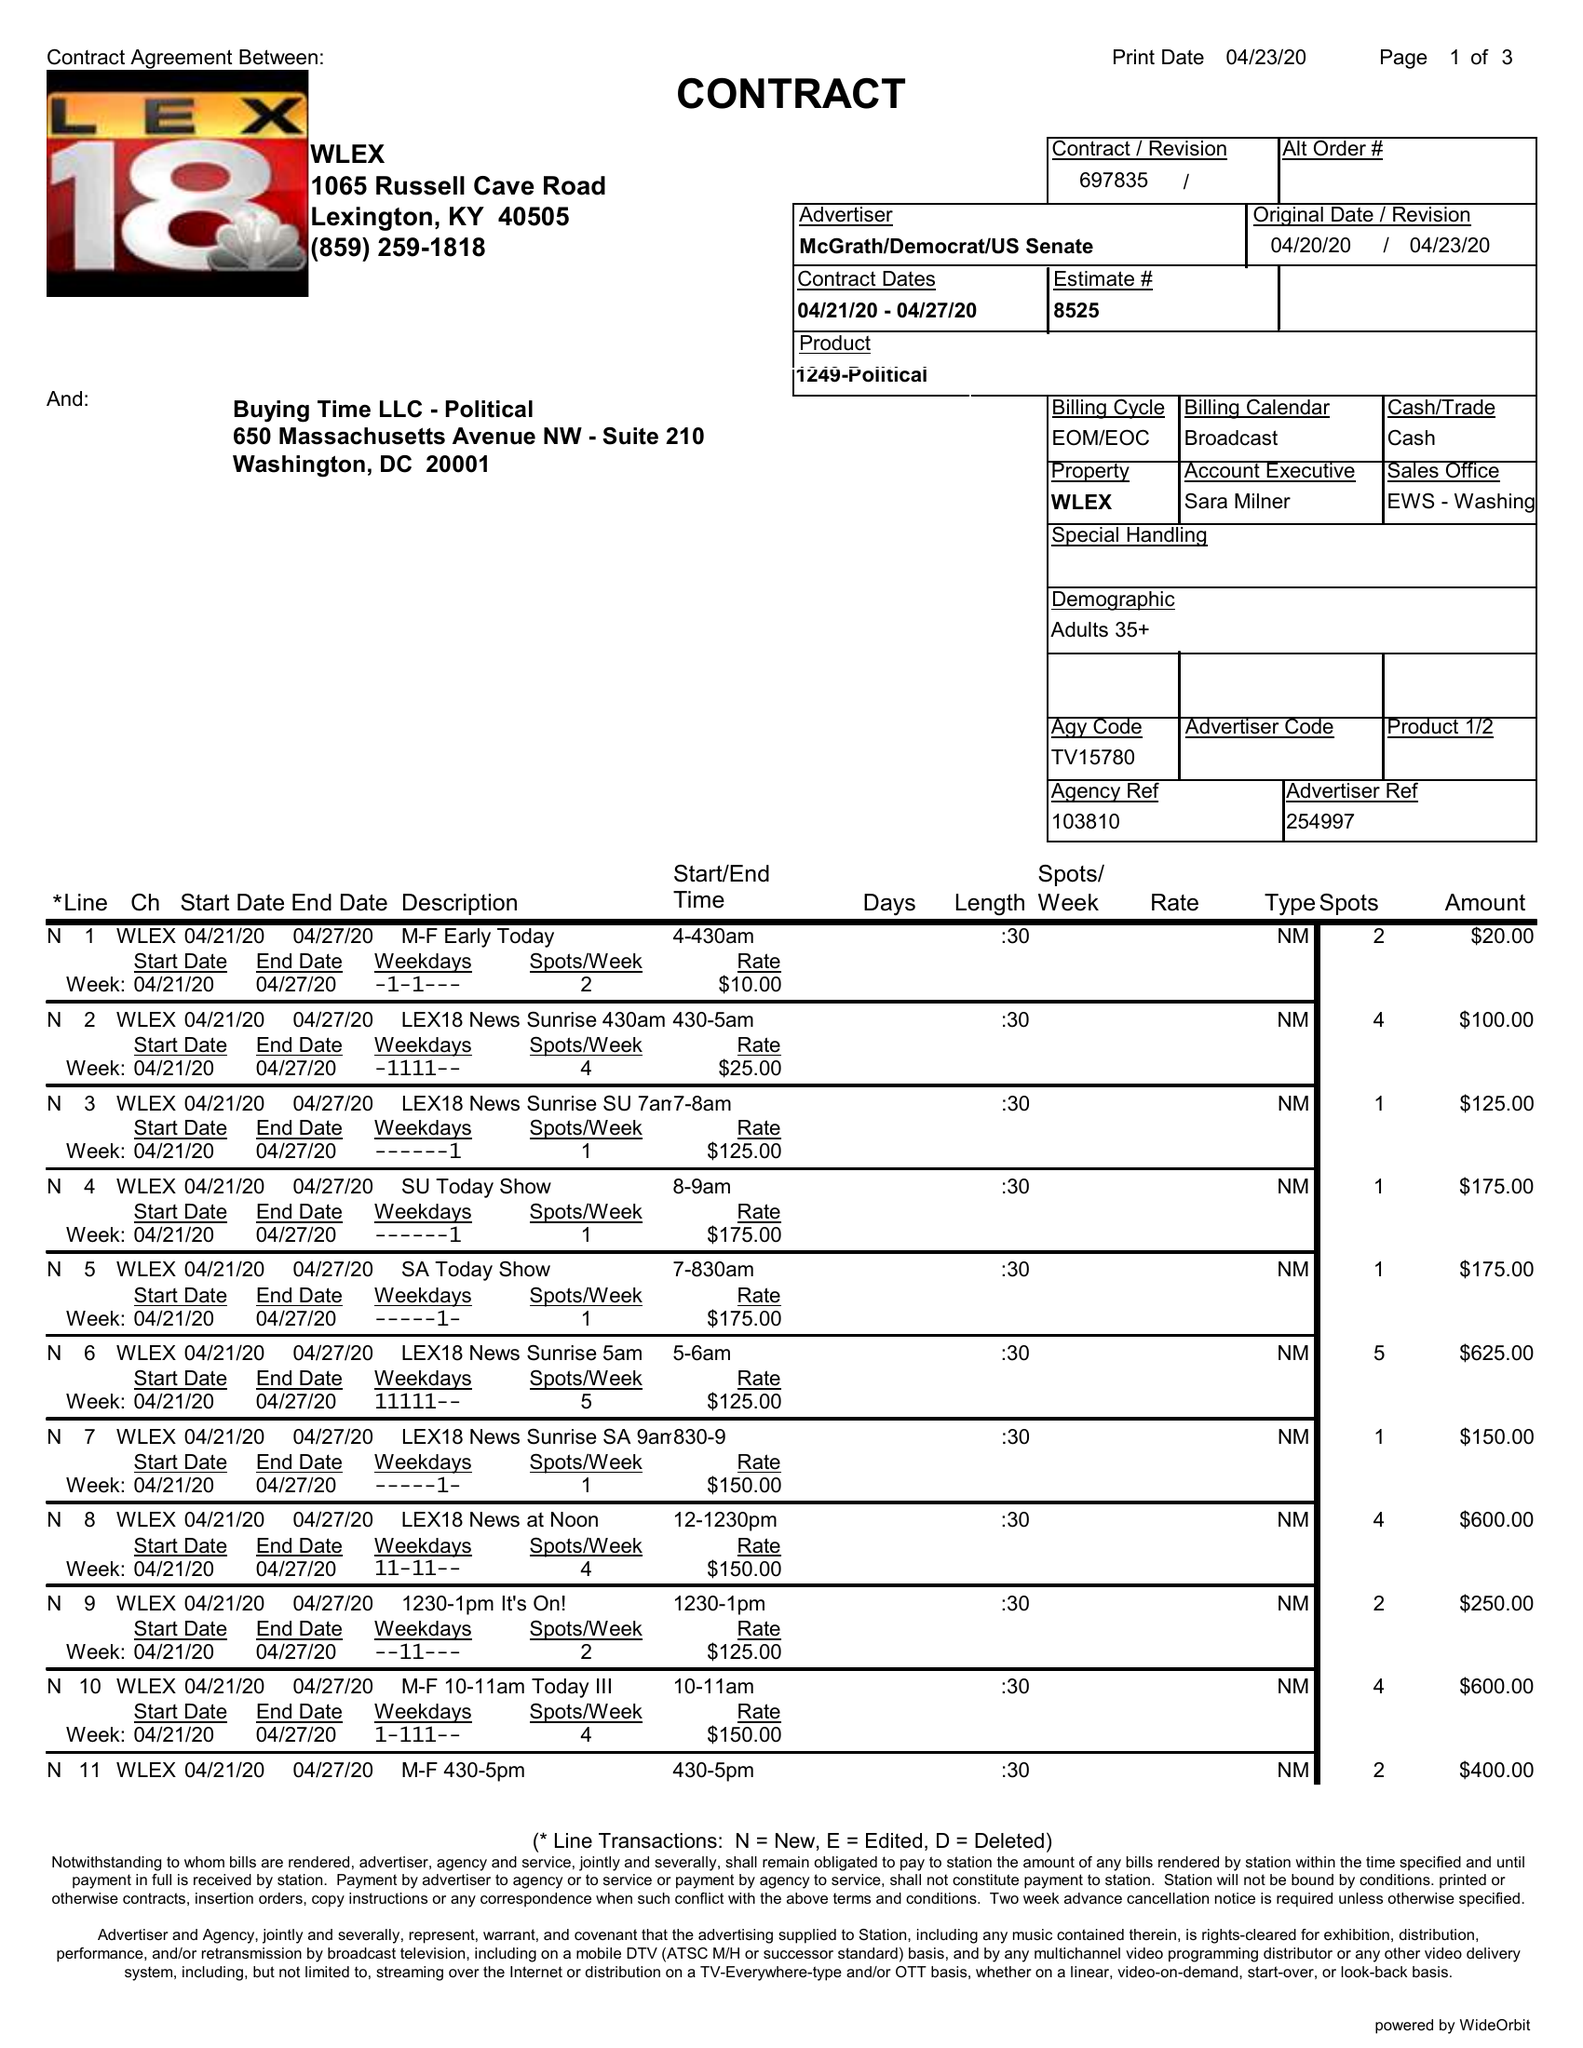What is the value for the flight_to?
Answer the question using a single word or phrase. 04/27/20 